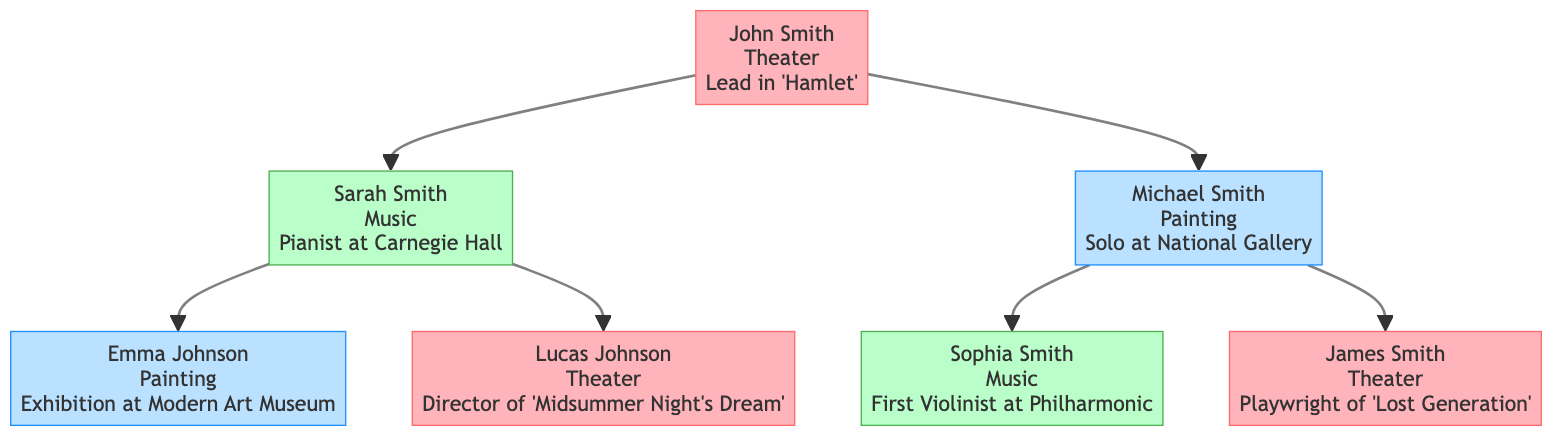What is John Smith's artistic pursuit? The diagram shows that John Smith is the patriarch of the family tree and indicates his artistic pursuit which is "Theater."
Answer: Theater Who is the grandson of John Smith with a portfolio highlight in painting? By tracing the children of John Smith, we find his son Michael Smith. His child, Emma Johnson, is listed as a granddaughter who has a portfolio highlight in "Painting."
Answer: Emma Johnson How many grandchildren does Sarah Smith have? Sarah Smith has two children listed: Emma Johnson and Lucas Johnson, meaning she has a total of two grandchildren.
Answer: 2 What is the portfolio highlight of Sophia Smith? Looking at the branch that includes Michael Smith and his children, we see that Sophia Smith's portfolio highlight is "First Violinist at the Philharmonic Orchestra."
Answer: First Violinist at the Philharmonic Orchestra Which artistic pursuit is associated with James Smith? By observing the section of the diagram related to Michael Smith's children, James Smith is explicitly linked to the artistic pursuit of "Theater."
Answer: Theater Who directed 'A Midsummer Night’s Dream'? The diagram highlights Lucas Johnson as the individual who has the role of director for "A Midsummer Night’s Dream," making him responsible for this project.
Answer: Lucas Johnson Identify the family member with the role of patriarch. The diagram identifies John Smith at the top, clearly marked as the patriarch of the family, indicating he holds the highest role.
Answer: John Smith What is the relationship between Michael Smith and Sophia Smith? Michael Smith is noted as the son of John Smith and is directly shown as the father of Sophia Smith, establishing a father-daughter relationship.
Answer: Father-Daughter How many artistic pursuits are represented in the diagram? The diagram contains three distinct artistic pursuits listed: Theater, Music, and Painting. Each of these is shown within various family members’ highlights, counting to a total of three.
Answer: 3 Which family member has a portfolio highlight of "Solo Exhibition at the National Gallery"? The diagram clearly lists Michael Smith with the portfolio highlight of "Solo Exhibition at the National Gallery," indicating his significant achievement in the world of painting.
Answer: Michael Smith 